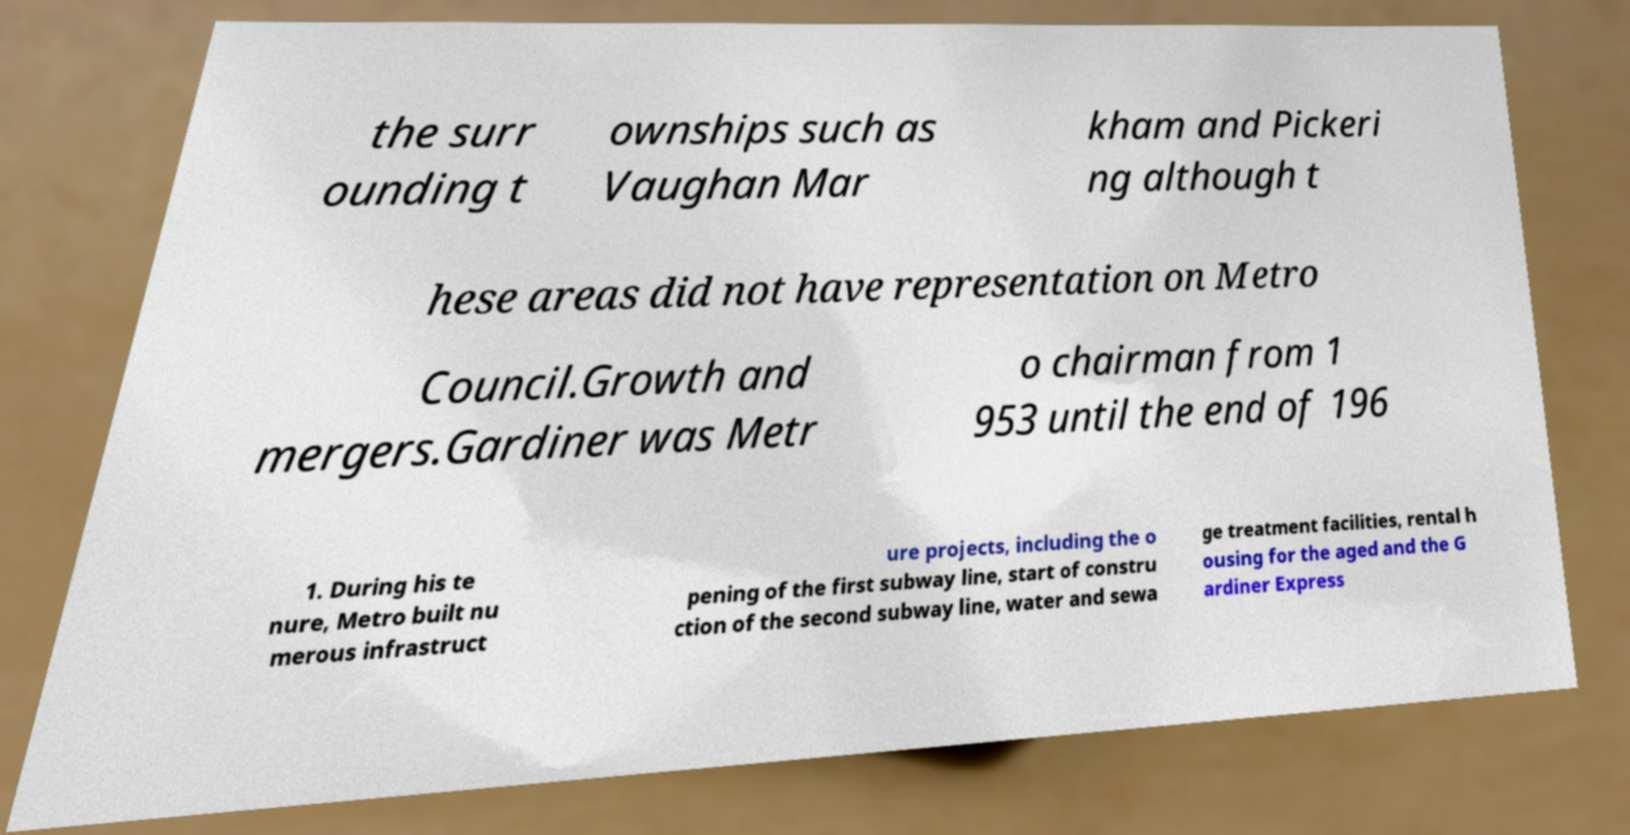For documentation purposes, I need the text within this image transcribed. Could you provide that? the surr ounding t ownships such as Vaughan Mar kham and Pickeri ng although t hese areas did not have representation on Metro Council.Growth and mergers.Gardiner was Metr o chairman from 1 953 until the end of 196 1. During his te nure, Metro built nu merous infrastruct ure projects, including the o pening of the first subway line, start of constru ction of the second subway line, water and sewa ge treatment facilities, rental h ousing for the aged and the G ardiner Express 